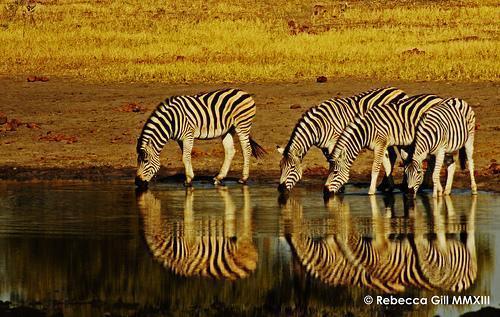How many zebras are there?
Give a very brief answer. 4. 